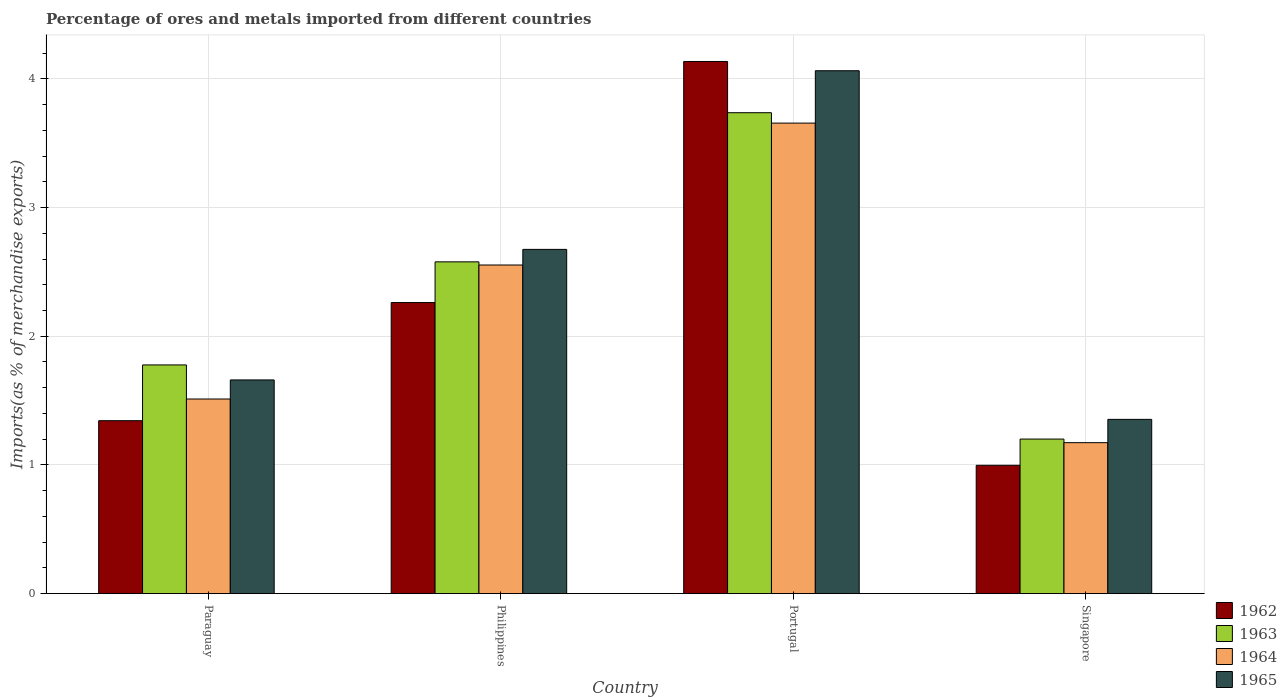How many different coloured bars are there?
Offer a very short reply. 4. Are the number of bars per tick equal to the number of legend labels?
Your answer should be compact. Yes. Are the number of bars on each tick of the X-axis equal?
Make the answer very short. Yes. How many bars are there on the 4th tick from the left?
Your answer should be very brief. 4. What is the label of the 1st group of bars from the left?
Your answer should be very brief. Paraguay. In how many cases, is the number of bars for a given country not equal to the number of legend labels?
Ensure brevity in your answer.  0. What is the percentage of imports to different countries in 1964 in Paraguay?
Your answer should be compact. 1.51. Across all countries, what is the maximum percentage of imports to different countries in 1965?
Give a very brief answer. 4.06. Across all countries, what is the minimum percentage of imports to different countries in 1963?
Provide a succinct answer. 1.2. In which country was the percentage of imports to different countries in 1962 maximum?
Ensure brevity in your answer.  Portugal. In which country was the percentage of imports to different countries in 1965 minimum?
Offer a terse response. Singapore. What is the total percentage of imports to different countries in 1965 in the graph?
Offer a terse response. 9.75. What is the difference between the percentage of imports to different countries in 1962 in Portugal and that in Singapore?
Keep it short and to the point. 3.14. What is the difference between the percentage of imports to different countries in 1965 in Singapore and the percentage of imports to different countries in 1964 in Paraguay?
Make the answer very short. -0.16. What is the average percentage of imports to different countries in 1963 per country?
Provide a short and direct response. 2.32. What is the difference between the percentage of imports to different countries of/in 1964 and percentage of imports to different countries of/in 1965 in Portugal?
Provide a succinct answer. -0.41. What is the ratio of the percentage of imports to different countries in 1963 in Paraguay to that in Philippines?
Your answer should be very brief. 0.69. Is the percentage of imports to different countries in 1965 in Portugal less than that in Singapore?
Your answer should be very brief. No. Is the difference between the percentage of imports to different countries in 1964 in Paraguay and Philippines greater than the difference between the percentage of imports to different countries in 1965 in Paraguay and Philippines?
Provide a short and direct response. No. What is the difference between the highest and the second highest percentage of imports to different countries in 1963?
Offer a very short reply. -0.8. What is the difference between the highest and the lowest percentage of imports to different countries in 1962?
Give a very brief answer. 3.14. In how many countries, is the percentage of imports to different countries in 1962 greater than the average percentage of imports to different countries in 1962 taken over all countries?
Offer a very short reply. 2. Is the sum of the percentage of imports to different countries in 1965 in Philippines and Portugal greater than the maximum percentage of imports to different countries in 1962 across all countries?
Make the answer very short. Yes. What does the 3rd bar from the left in Portugal represents?
Your response must be concise. 1964. How many bars are there?
Your answer should be very brief. 16. How many countries are there in the graph?
Keep it short and to the point. 4. What is the difference between two consecutive major ticks on the Y-axis?
Your answer should be very brief. 1. Are the values on the major ticks of Y-axis written in scientific E-notation?
Your answer should be compact. No. Where does the legend appear in the graph?
Offer a terse response. Bottom right. How many legend labels are there?
Give a very brief answer. 4. What is the title of the graph?
Give a very brief answer. Percentage of ores and metals imported from different countries. What is the label or title of the X-axis?
Your answer should be very brief. Country. What is the label or title of the Y-axis?
Give a very brief answer. Imports(as % of merchandise exports). What is the Imports(as % of merchandise exports) of 1962 in Paraguay?
Keep it short and to the point. 1.34. What is the Imports(as % of merchandise exports) of 1963 in Paraguay?
Give a very brief answer. 1.78. What is the Imports(as % of merchandise exports) in 1964 in Paraguay?
Keep it short and to the point. 1.51. What is the Imports(as % of merchandise exports) in 1965 in Paraguay?
Ensure brevity in your answer.  1.66. What is the Imports(as % of merchandise exports) in 1962 in Philippines?
Ensure brevity in your answer.  2.26. What is the Imports(as % of merchandise exports) in 1963 in Philippines?
Offer a terse response. 2.58. What is the Imports(as % of merchandise exports) in 1964 in Philippines?
Provide a short and direct response. 2.55. What is the Imports(as % of merchandise exports) of 1965 in Philippines?
Offer a terse response. 2.67. What is the Imports(as % of merchandise exports) of 1962 in Portugal?
Ensure brevity in your answer.  4.13. What is the Imports(as % of merchandise exports) of 1963 in Portugal?
Give a very brief answer. 3.74. What is the Imports(as % of merchandise exports) of 1964 in Portugal?
Give a very brief answer. 3.66. What is the Imports(as % of merchandise exports) in 1965 in Portugal?
Provide a succinct answer. 4.06. What is the Imports(as % of merchandise exports) of 1962 in Singapore?
Offer a very short reply. 1. What is the Imports(as % of merchandise exports) in 1963 in Singapore?
Ensure brevity in your answer.  1.2. What is the Imports(as % of merchandise exports) in 1964 in Singapore?
Provide a succinct answer. 1.17. What is the Imports(as % of merchandise exports) in 1965 in Singapore?
Offer a very short reply. 1.35. Across all countries, what is the maximum Imports(as % of merchandise exports) of 1962?
Your answer should be compact. 4.13. Across all countries, what is the maximum Imports(as % of merchandise exports) in 1963?
Give a very brief answer. 3.74. Across all countries, what is the maximum Imports(as % of merchandise exports) of 1964?
Your answer should be compact. 3.66. Across all countries, what is the maximum Imports(as % of merchandise exports) in 1965?
Give a very brief answer. 4.06. Across all countries, what is the minimum Imports(as % of merchandise exports) in 1962?
Ensure brevity in your answer.  1. Across all countries, what is the minimum Imports(as % of merchandise exports) of 1963?
Keep it short and to the point. 1.2. Across all countries, what is the minimum Imports(as % of merchandise exports) of 1964?
Ensure brevity in your answer.  1.17. Across all countries, what is the minimum Imports(as % of merchandise exports) in 1965?
Provide a short and direct response. 1.35. What is the total Imports(as % of merchandise exports) in 1962 in the graph?
Keep it short and to the point. 8.74. What is the total Imports(as % of merchandise exports) in 1963 in the graph?
Give a very brief answer. 9.29. What is the total Imports(as % of merchandise exports) of 1964 in the graph?
Provide a short and direct response. 8.89. What is the total Imports(as % of merchandise exports) in 1965 in the graph?
Provide a succinct answer. 9.75. What is the difference between the Imports(as % of merchandise exports) in 1962 in Paraguay and that in Philippines?
Offer a terse response. -0.92. What is the difference between the Imports(as % of merchandise exports) of 1963 in Paraguay and that in Philippines?
Give a very brief answer. -0.8. What is the difference between the Imports(as % of merchandise exports) in 1964 in Paraguay and that in Philippines?
Give a very brief answer. -1.04. What is the difference between the Imports(as % of merchandise exports) of 1965 in Paraguay and that in Philippines?
Give a very brief answer. -1.01. What is the difference between the Imports(as % of merchandise exports) of 1962 in Paraguay and that in Portugal?
Ensure brevity in your answer.  -2.79. What is the difference between the Imports(as % of merchandise exports) in 1963 in Paraguay and that in Portugal?
Offer a very short reply. -1.96. What is the difference between the Imports(as % of merchandise exports) of 1964 in Paraguay and that in Portugal?
Provide a short and direct response. -2.14. What is the difference between the Imports(as % of merchandise exports) in 1965 in Paraguay and that in Portugal?
Give a very brief answer. -2.4. What is the difference between the Imports(as % of merchandise exports) in 1962 in Paraguay and that in Singapore?
Your answer should be very brief. 0.35. What is the difference between the Imports(as % of merchandise exports) in 1963 in Paraguay and that in Singapore?
Your response must be concise. 0.58. What is the difference between the Imports(as % of merchandise exports) of 1964 in Paraguay and that in Singapore?
Your response must be concise. 0.34. What is the difference between the Imports(as % of merchandise exports) in 1965 in Paraguay and that in Singapore?
Ensure brevity in your answer.  0.31. What is the difference between the Imports(as % of merchandise exports) in 1962 in Philippines and that in Portugal?
Ensure brevity in your answer.  -1.87. What is the difference between the Imports(as % of merchandise exports) of 1963 in Philippines and that in Portugal?
Your answer should be compact. -1.16. What is the difference between the Imports(as % of merchandise exports) of 1964 in Philippines and that in Portugal?
Provide a succinct answer. -1.1. What is the difference between the Imports(as % of merchandise exports) of 1965 in Philippines and that in Portugal?
Offer a terse response. -1.39. What is the difference between the Imports(as % of merchandise exports) of 1962 in Philippines and that in Singapore?
Offer a very short reply. 1.26. What is the difference between the Imports(as % of merchandise exports) in 1963 in Philippines and that in Singapore?
Keep it short and to the point. 1.38. What is the difference between the Imports(as % of merchandise exports) of 1964 in Philippines and that in Singapore?
Give a very brief answer. 1.38. What is the difference between the Imports(as % of merchandise exports) in 1965 in Philippines and that in Singapore?
Your response must be concise. 1.32. What is the difference between the Imports(as % of merchandise exports) in 1962 in Portugal and that in Singapore?
Ensure brevity in your answer.  3.14. What is the difference between the Imports(as % of merchandise exports) in 1963 in Portugal and that in Singapore?
Ensure brevity in your answer.  2.54. What is the difference between the Imports(as % of merchandise exports) in 1964 in Portugal and that in Singapore?
Offer a terse response. 2.48. What is the difference between the Imports(as % of merchandise exports) in 1965 in Portugal and that in Singapore?
Offer a terse response. 2.71. What is the difference between the Imports(as % of merchandise exports) in 1962 in Paraguay and the Imports(as % of merchandise exports) in 1963 in Philippines?
Your answer should be compact. -1.23. What is the difference between the Imports(as % of merchandise exports) of 1962 in Paraguay and the Imports(as % of merchandise exports) of 1964 in Philippines?
Your answer should be very brief. -1.21. What is the difference between the Imports(as % of merchandise exports) of 1962 in Paraguay and the Imports(as % of merchandise exports) of 1965 in Philippines?
Keep it short and to the point. -1.33. What is the difference between the Imports(as % of merchandise exports) in 1963 in Paraguay and the Imports(as % of merchandise exports) in 1964 in Philippines?
Your response must be concise. -0.78. What is the difference between the Imports(as % of merchandise exports) of 1963 in Paraguay and the Imports(as % of merchandise exports) of 1965 in Philippines?
Your answer should be compact. -0.9. What is the difference between the Imports(as % of merchandise exports) of 1964 in Paraguay and the Imports(as % of merchandise exports) of 1965 in Philippines?
Offer a terse response. -1.16. What is the difference between the Imports(as % of merchandise exports) in 1962 in Paraguay and the Imports(as % of merchandise exports) in 1963 in Portugal?
Provide a succinct answer. -2.39. What is the difference between the Imports(as % of merchandise exports) in 1962 in Paraguay and the Imports(as % of merchandise exports) in 1964 in Portugal?
Provide a succinct answer. -2.31. What is the difference between the Imports(as % of merchandise exports) of 1962 in Paraguay and the Imports(as % of merchandise exports) of 1965 in Portugal?
Make the answer very short. -2.72. What is the difference between the Imports(as % of merchandise exports) of 1963 in Paraguay and the Imports(as % of merchandise exports) of 1964 in Portugal?
Keep it short and to the point. -1.88. What is the difference between the Imports(as % of merchandise exports) in 1963 in Paraguay and the Imports(as % of merchandise exports) in 1965 in Portugal?
Provide a short and direct response. -2.29. What is the difference between the Imports(as % of merchandise exports) in 1964 in Paraguay and the Imports(as % of merchandise exports) in 1965 in Portugal?
Provide a short and direct response. -2.55. What is the difference between the Imports(as % of merchandise exports) of 1962 in Paraguay and the Imports(as % of merchandise exports) of 1963 in Singapore?
Your answer should be compact. 0.14. What is the difference between the Imports(as % of merchandise exports) of 1962 in Paraguay and the Imports(as % of merchandise exports) of 1964 in Singapore?
Your answer should be compact. 0.17. What is the difference between the Imports(as % of merchandise exports) of 1962 in Paraguay and the Imports(as % of merchandise exports) of 1965 in Singapore?
Your answer should be compact. -0.01. What is the difference between the Imports(as % of merchandise exports) of 1963 in Paraguay and the Imports(as % of merchandise exports) of 1964 in Singapore?
Make the answer very short. 0.6. What is the difference between the Imports(as % of merchandise exports) in 1963 in Paraguay and the Imports(as % of merchandise exports) in 1965 in Singapore?
Your answer should be compact. 0.42. What is the difference between the Imports(as % of merchandise exports) in 1964 in Paraguay and the Imports(as % of merchandise exports) in 1965 in Singapore?
Offer a terse response. 0.16. What is the difference between the Imports(as % of merchandise exports) of 1962 in Philippines and the Imports(as % of merchandise exports) of 1963 in Portugal?
Offer a terse response. -1.47. What is the difference between the Imports(as % of merchandise exports) in 1962 in Philippines and the Imports(as % of merchandise exports) in 1964 in Portugal?
Your answer should be very brief. -1.39. What is the difference between the Imports(as % of merchandise exports) of 1962 in Philippines and the Imports(as % of merchandise exports) of 1965 in Portugal?
Offer a terse response. -1.8. What is the difference between the Imports(as % of merchandise exports) in 1963 in Philippines and the Imports(as % of merchandise exports) in 1964 in Portugal?
Make the answer very short. -1.08. What is the difference between the Imports(as % of merchandise exports) of 1963 in Philippines and the Imports(as % of merchandise exports) of 1965 in Portugal?
Ensure brevity in your answer.  -1.48. What is the difference between the Imports(as % of merchandise exports) of 1964 in Philippines and the Imports(as % of merchandise exports) of 1965 in Portugal?
Your answer should be very brief. -1.51. What is the difference between the Imports(as % of merchandise exports) of 1962 in Philippines and the Imports(as % of merchandise exports) of 1963 in Singapore?
Provide a succinct answer. 1.06. What is the difference between the Imports(as % of merchandise exports) in 1962 in Philippines and the Imports(as % of merchandise exports) in 1964 in Singapore?
Your response must be concise. 1.09. What is the difference between the Imports(as % of merchandise exports) in 1962 in Philippines and the Imports(as % of merchandise exports) in 1965 in Singapore?
Offer a terse response. 0.91. What is the difference between the Imports(as % of merchandise exports) in 1963 in Philippines and the Imports(as % of merchandise exports) in 1964 in Singapore?
Offer a very short reply. 1.4. What is the difference between the Imports(as % of merchandise exports) in 1963 in Philippines and the Imports(as % of merchandise exports) in 1965 in Singapore?
Offer a terse response. 1.22. What is the difference between the Imports(as % of merchandise exports) in 1964 in Philippines and the Imports(as % of merchandise exports) in 1965 in Singapore?
Offer a very short reply. 1.2. What is the difference between the Imports(as % of merchandise exports) of 1962 in Portugal and the Imports(as % of merchandise exports) of 1963 in Singapore?
Provide a succinct answer. 2.93. What is the difference between the Imports(as % of merchandise exports) in 1962 in Portugal and the Imports(as % of merchandise exports) in 1964 in Singapore?
Your answer should be compact. 2.96. What is the difference between the Imports(as % of merchandise exports) in 1962 in Portugal and the Imports(as % of merchandise exports) in 1965 in Singapore?
Your answer should be very brief. 2.78. What is the difference between the Imports(as % of merchandise exports) in 1963 in Portugal and the Imports(as % of merchandise exports) in 1964 in Singapore?
Provide a succinct answer. 2.56. What is the difference between the Imports(as % of merchandise exports) of 1963 in Portugal and the Imports(as % of merchandise exports) of 1965 in Singapore?
Your response must be concise. 2.38. What is the difference between the Imports(as % of merchandise exports) in 1964 in Portugal and the Imports(as % of merchandise exports) in 1965 in Singapore?
Ensure brevity in your answer.  2.3. What is the average Imports(as % of merchandise exports) in 1962 per country?
Ensure brevity in your answer.  2.18. What is the average Imports(as % of merchandise exports) of 1963 per country?
Your answer should be compact. 2.32. What is the average Imports(as % of merchandise exports) in 1964 per country?
Your response must be concise. 2.22. What is the average Imports(as % of merchandise exports) of 1965 per country?
Provide a succinct answer. 2.44. What is the difference between the Imports(as % of merchandise exports) in 1962 and Imports(as % of merchandise exports) in 1963 in Paraguay?
Provide a succinct answer. -0.43. What is the difference between the Imports(as % of merchandise exports) of 1962 and Imports(as % of merchandise exports) of 1964 in Paraguay?
Your response must be concise. -0.17. What is the difference between the Imports(as % of merchandise exports) in 1962 and Imports(as % of merchandise exports) in 1965 in Paraguay?
Make the answer very short. -0.32. What is the difference between the Imports(as % of merchandise exports) of 1963 and Imports(as % of merchandise exports) of 1964 in Paraguay?
Make the answer very short. 0.26. What is the difference between the Imports(as % of merchandise exports) of 1963 and Imports(as % of merchandise exports) of 1965 in Paraguay?
Make the answer very short. 0.12. What is the difference between the Imports(as % of merchandise exports) of 1964 and Imports(as % of merchandise exports) of 1965 in Paraguay?
Make the answer very short. -0.15. What is the difference between the Imports(as % of merchandise exports) of 1962 and Imports(as % of merchandise exports) of 1963 in Philippines?
Ensure brevity in your answer.  -0.32. What is the difference between the Imports(as % of merchandise exports) of 1962 and Imports(as % of merchandise exports) of 1964 in Philippines?
Keep it short and to the point. -0.29. What is the difference between the Imports(as % of merchandise exports) of 1962 and Imports(as % of merchandise exports) of 1965 in Philippines?
Provide a succinct answer. -0.41. What is the difference between the Imports(as % of merchandise exports) of 1963 and Imports(as % of merchandise exports) of 1964 in Philippines?
Ensure brevity in your answer.  0.02. What is the difference between the Imports(as % of merchandise exports) of 1963 and Imports(as % of merchandise exports) of 1965 in Philippines?
Your answer should be compact. -0.1. What is the difference between the Imports(as % of merchandise exports) in 1964 and Imports(as % of merchandise exports) in 1965 in Philippines?
Give a very brief answer. -0.12. What is the difference between the Imports(as % of merchandise exports) of 1962 and Imports(as % of merchandise exports) of 1963 in Portugal?
Ensure brevity in your answer.  0.4. What is the difference between the Imports(as % of merchandise exports) in 1962 and Imports(as % of merchandise exports) in 1964 in Portugal?
Provide a short and direct response. 0.48. What is the difference between the Imports(as % of merchandise exports) of 1962 and Imports(as % of merchandise exports) of 1965 in Portugal?
Keep it short and to the point. 0.07. What is the difference between the Imports(as % of merchandise exports) of 1963 and Imports(as % of merchandise exports) of 1964 in Portugal?
Offer a very short reply. 0.08. What is the difference between the Imports(as % of merchandise exports) of 1963 and Imports(as % of merchandise exports) of 1965 in Portugal?
Offer a very short reply. -0.33. What is the difference between the Imports(as % of merchandise exports) of 1964 and Imports(as % of merchandise exports) of 1965 in Portugal?
Your answer should be compact. -0.41. What is the difference between the Imports(as % of merchandise exports) in 1962 and Imports(as % of merchandise exports) in 1963 in Singapore?
Your answer should be compact. -0.2. What is the difference between the Imports(as % of merchandise exports) in 1962 and Imports(as % of merchandise exports) in 1964 in Singapore?
Offer a terse response. -0.18. What is the difference between the Imports(as % of merchandise exports) of 1962 and Imports(as % of merchandise exports) of 1965 in Singapore?
Ensure brevity in your answer.  -0.36. What is the difference between the Imports(as % of merchandise exports) of 1963 and Imports(as % of merchandise exports) of 1964 in Singapore?
Your answer should be very brief. 0.03. What is the difference between the Imports(as % of merchandise exports) of 1963 and Imports(as % of merchandise exports) of 1965 in Singapore?
Your answer should be very brief. -0.15. What is the difference between the Imports(as % of merchandise exports) in 1964 and Imports(as % of merchandise exports) in 1965 in Singapore?
Your answer should be very brief. -0.18. What is the ratio of the Imports(as % of merchandise exports) of 1962 in Paraguay to that in Philippines?
Your response must be concise. 0.59. What is the ratio of the Imports(as % of merchandise exports) of 1963 in Paraguay to that in Philippines?
Your response must be concise. 0.69. What is the ratio of the Imports(as % of merchandise exports) in 1964 in Paraguay to that in Philippines?
Offer a terse response. 0.59. What is the ratio of the Imports(as % of merchandise exports) of 1965 in Paraguay to that in Philippines?
Ensure brevity in your answer.  0.62. What is the ratio of the Imports(as % of merchandise exports) of 1962 in Paraguay to that in Portugal?
Your response must be concise. 0.33. What is the ratio of the Imports(as % of merchandise exports) in 1963 in Paraguay to that in Portugal?
Give a very brief answer. 0.48. What is the ratio of the Imports(as % of merchandise exports) in 1964 in Paraguay to that in Portugal?
Make the answer very short. 0.41. What is the ratio of the Imports(as % of merchandise exports) in 1965 in Paraguay to that in Portugal?
Give a very brief answer. 0.41. What is the ratio of the Imports(as % of merchandise exports) of 1962 in Paraguay to that in Singapore?
Your answer should be compact. 1.35. What is the ratio of the Imports(as % of merchandise exports) in 1963 in Paraguay to that in Singapore?
Provide a short and direct response. 1.48. What is the ratio of the Imports(as % of merchandise exports) in 1964 in Paraguay to that in Singapore?
Your response must be concise. 1.29. What is the ratio of the Imports(as % of merchandise exports) of 1965 in Paraguay to that in Singapore?
Keep it short and to the point. 1.23. What is the ratio of the Imports(as % of merchandise exports) of 1962 in Philippines to that in Portugal?
Give a very brief answer. 0.55. What is the ratio of the Imports(as % of merchandise exports) in 1963 in Philippines to that in Portugal?
Provide a succinct answer. 0.69. What is the ratio of the Imports(as % of merchandise exports) of 1964 in Philippines to that in Portugal?
Keep it short and to the point. 0.7. What is the ratio of the Imports(as % of merchandise exports) of 1965 in Philippines to that in Portugal?
Offer a very short reply. 0.66. What is the ratio of the Imports(as % of merchandise exports) of 1962 in Philippines to that in Singapore?
Provide a short and direct response. 2.27. What is the ratio of the Imports(as % of merchandise exports) of 1963 in Philippines to that in Singapore?
Your answer should be compact. 2.15. What is the ratio of the Imports(as % of merchandise exports) of 1964 in Philippines to that in Singapore?
Give a very brief answer. 2.18. What is the ratio of the Imports(as % of merchandise exports) of 1965 in Philippines to that in Singapore?
Your response must be concise. 1.98. What is the ratio of the Imports(as % of merchandise exports) in 1962 in Portugal to that in Singapore?
Provide a succinct answer. 4.15. What is the ratio of the Imports(as % of merchandise exports) of 1963 in Portugal to that in Singapore?
Ensure brevity in your answer.  3.11. What is the ratio of the Imports(as % of merchandise exports) of 1964 in Portugal to that in Singapore?
Your answer should be compact. 3.12. What is the ratio of the Imports(as % of merchandise exports) of 1965 in Portugal to that in Singapore?
Your response must be concise. 3. What is the difference between the highest and the second highest Imports(as % of merchandise exports) of 1962?
Your answer should be compact. 1.87. What is the difference between the highest and the second highest Imports(as % of merchandise exports) in 1963?
Provide a succinct answer. 1.16. What is the difference between the highest and the second highest Imports(as % of merchandise exports) of 1964?
Your response must be concise. 1.1. What is the difference between the highest and the second highest Imports(as % of merchandise exports) in 1965?
Offer a very short reply. 1.39. What is the difference between the highest and the lowest Imports(as % of merchandise exports) in 1962?
Offer a very short reply. 3.14. What is the difference between the highest and the lowest Imports(as % of merchandise exports) of 1963?
Ensure brevity in your answer.  2.54. What is the difference between the highest and the lowest Imports(as % of merchandise exports) in 1964?
Your response must be concise. 2.48. What is the difference between the highest and the lowest Imports(as % of merchandise exports) of 1965?
Provide a short and direct response. 2.71. 